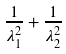Convert formula to latex. <formula><loc_0><loc_0><loc_500><loc_500>\frac { 1 } { \lambda _ { 1 } ^ { 2 } } + \frac { 1 } { \lambda _ { 2 } ^ { 2 } }</formula> 